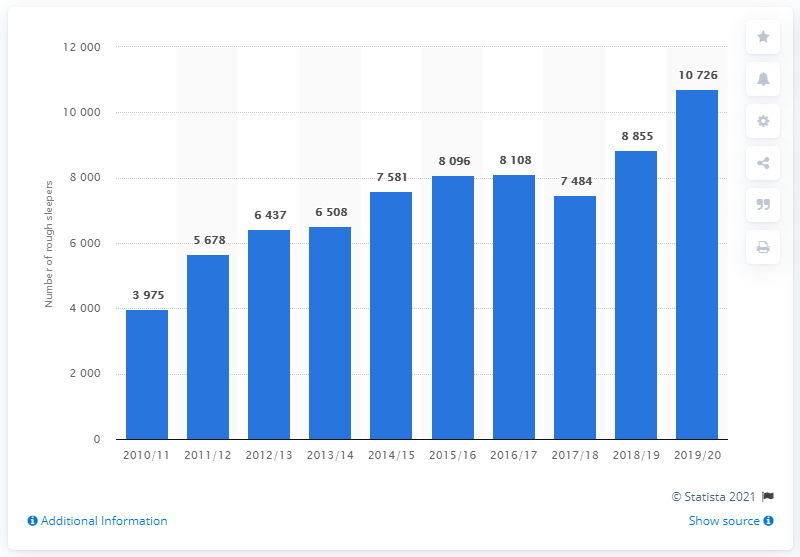Mention a couple of crucial points in this snapshot. In the 2019/2020 fiscal year, it was reported that there were 10,726 people experiencing homelessness in London, with an emphasis on those sleeping rough on any given night. 